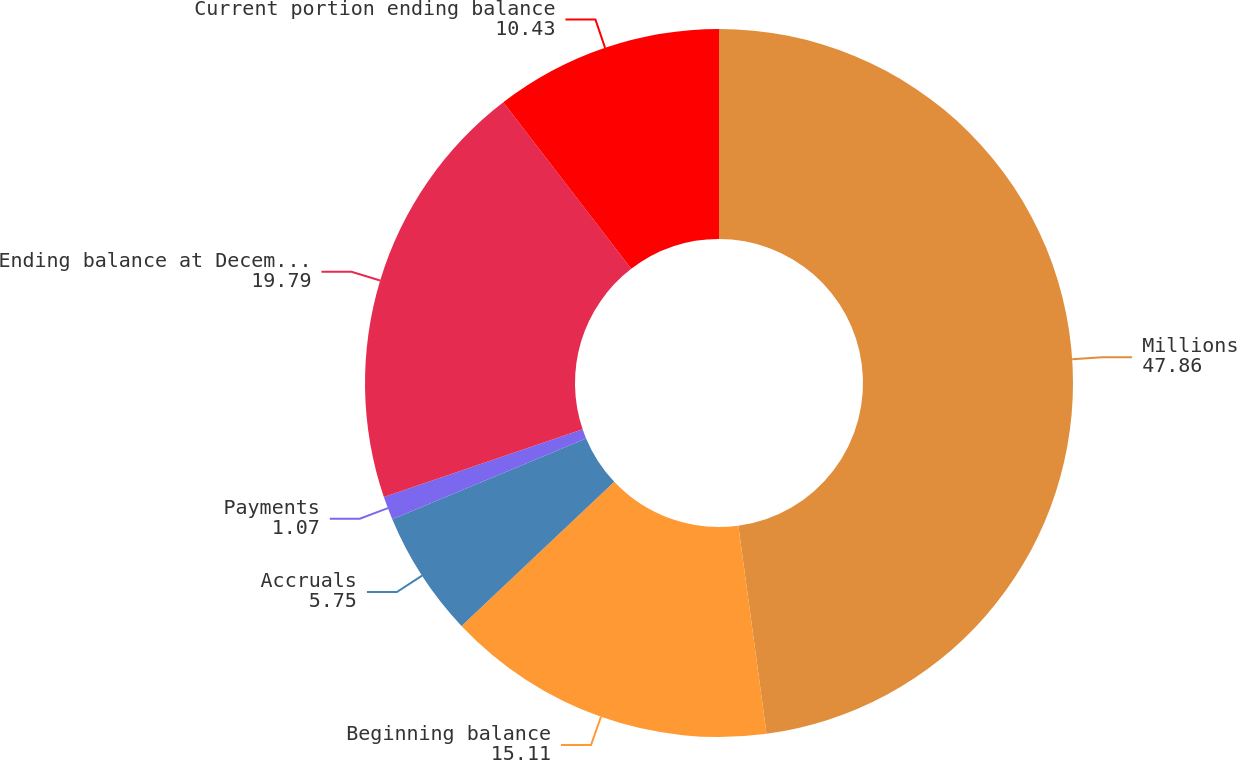Convert chart. <chart><loc_0><loc_0><loc_500><loc_500><pie_chart><fcel>Millions<fcel>Beginning balance<fcel>Accruals<fcel>Payments<fcel>Ending balance at December 31<fcel>Current portion ending balance<nl><fcel>47.86%<fcel>15.11%<fcel>5.75%<fcel>1.07%<fcel>19.79%<fcel>10.43%<nl></chart> 